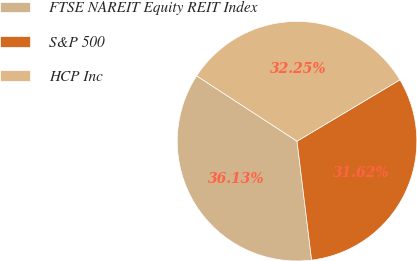Convert chart to OTSL. <chart><loc_0><loc_0><loc_500><loc_500><pie_chart><fcel>FTSE NAREIT Equity REIT Index<fcel>S&P 500<fcel>HCP Inc<nl><fcel>36.13%<fcel>31.62%<fcel>32.25%<nl></chart> 